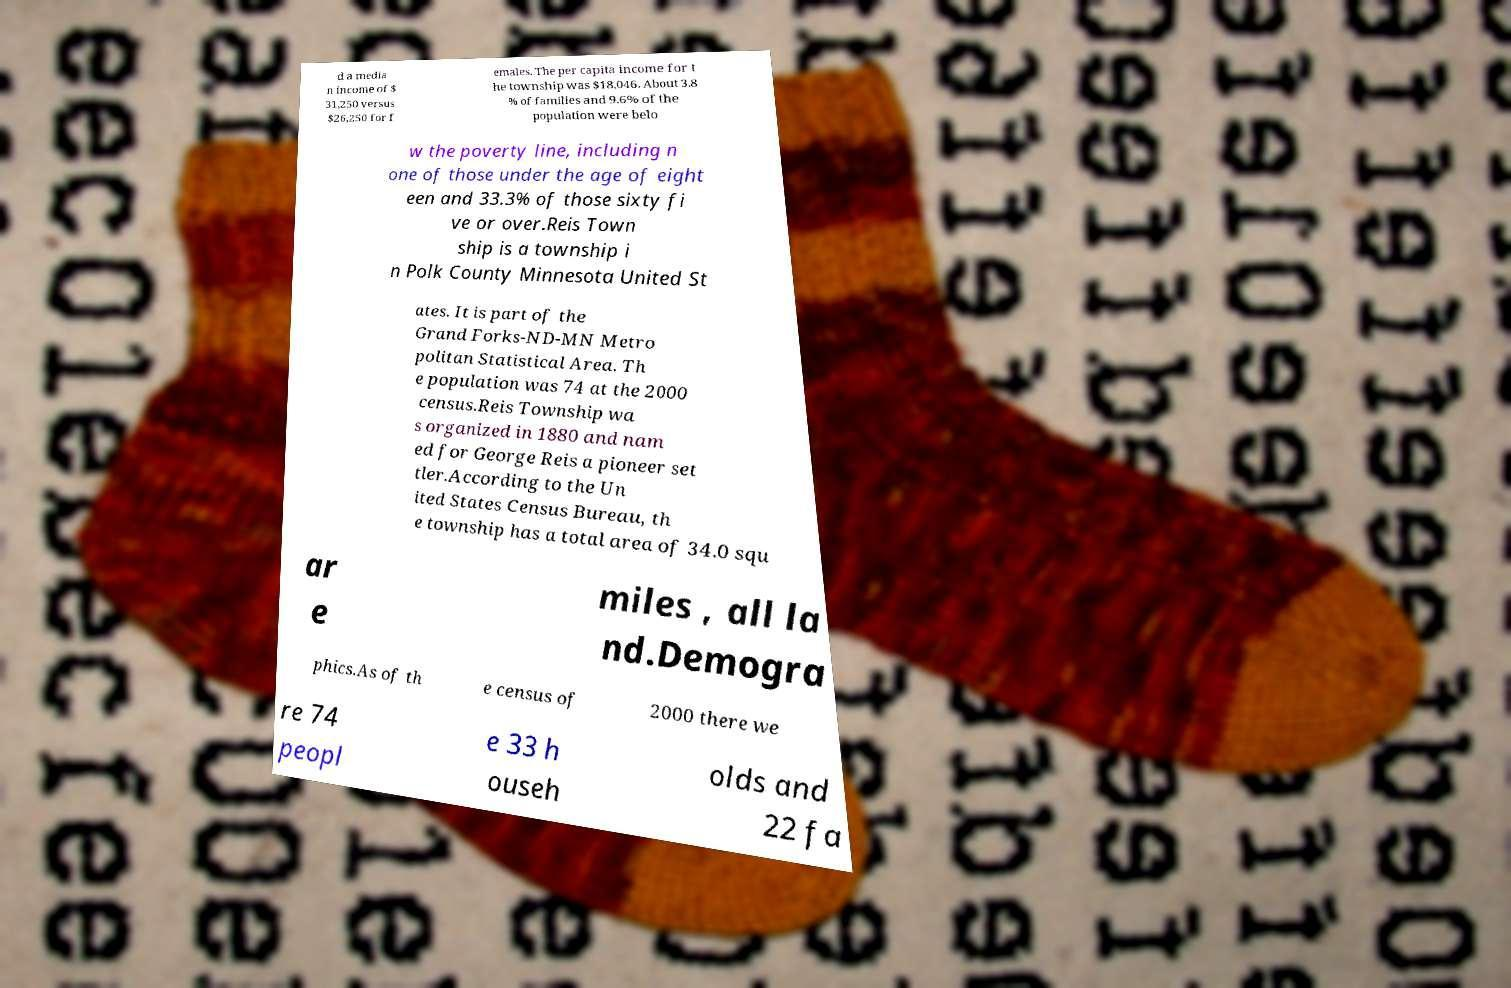What messages or text are displayed in this image? I need them in a readable, typed format. d a media n income of $ 31,250 versus $26,250 for f emales. The per capita income for t he township was $18,046. About 3.8 % of families and 9.6% of the population were belo w the poverty line, including n one of those under the age of eight een and 33.3% of those sixty fi ve or over.Reis Town ship is a township i n Polk County Minnesota United St ates. It is part of the Grand Forks-ND-MN Metro politan Statistical Area. Th e population was 74 at the 2000 census.Reis Township wa s organized in 1880 and nam ed for George Reis a pioneer set tler.According to the Un ited States Census Bureau, th e township has a total area of 34.0 squ ar e miles , all la nd.Demogra phics.As of th e census of 2000 there we re 74 peopl e 33 h ouseh olds and 22 fa 